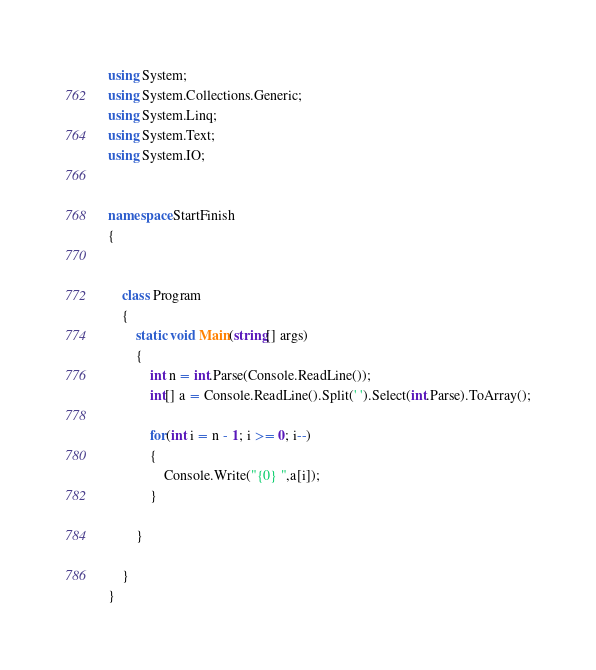Convert code to text. <code><loc_0><loc_0><loc_500><loc_500><_C#_>
using System;
using System.Collections.Generic;
using System.Linq;
using System.Text;
using System.IO;


namespace StartFinish
{
 

    class Program
    {
        static void Main(string[] args)
        {
            int n = int.Parse(Console.ReadLine());
            int[] a = Console.ReadLine().Split(' ').Select(int.Parse).ToArray();

            for(int i = n - 1; i >= 0; i--)
            {
                Console.Write("{0} ",a[i]);
            }

        }
        
    }
}</code> 